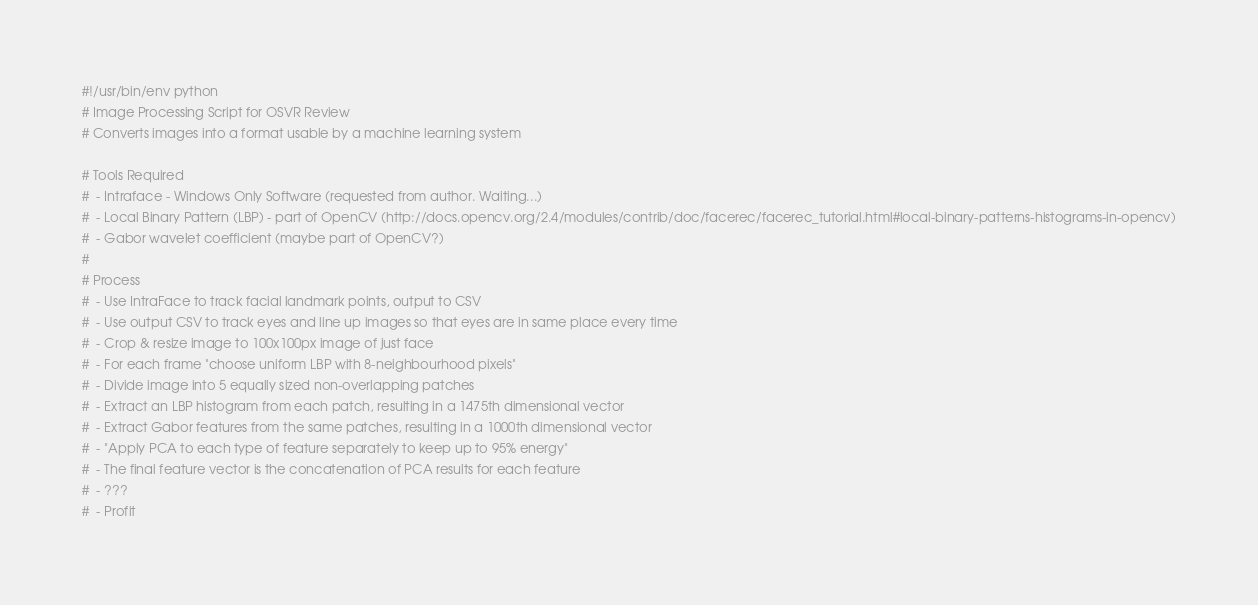<code> <loc_0><loc_0><loc_500><loc_500><_Python_>#!/usr/bin/env python
# Image Processing Script for OSVR Review
# Converts images into a format usable by a machine learning system

# Tools Required
#  - Intraface - Windows Only Software (requested from author. Waiting...)
#  - Local Binary Pattern (LBP) - part of OpenCV (http://docs.opencv.org/2.4/modules/contrib/doc/facerec/facerec_tutorial.html#local-binary-patterns-histograms-in-opencv)
#  - Gabor wavelet coefficient (maybe part of OpenCV?)
#
# Process
#  - Use IntraFace to track facial landmark points, output to CSV
#  - Use output CSV to track eyes and line up images so that eyes are in same place every time
#  - Crop & resize image to 100x100px image of just face
#  - For each frame "choose uniform LBP with 8-neighbourhood pixels"
#  - Divide image into 5 equally sized non-overlapping patches
#  - Extract an LBP histogram from each patch, resulting in a 1475th dimensional vector
#  - Extract Gabor features from the same patches, resulting in a 1000th dimensional vector
#  - "Apply PCA to each type of feature separately to keep up to 95% energy"
#  - The final feature vector is the concatenation of PCA results for each feature
#  - ???
#  - Profit


</code> 